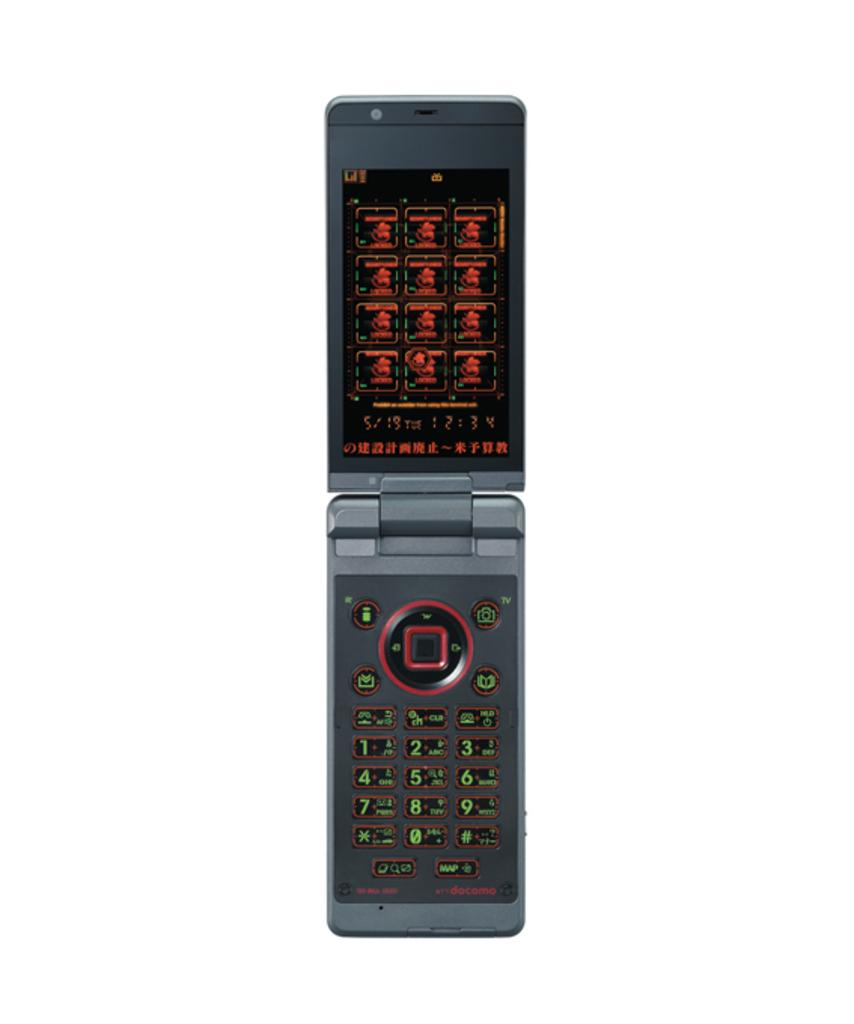<image>
Relay a brief, clear account of the picture shown. A Docomo brand flip phone open with the number in green and the screen in red 